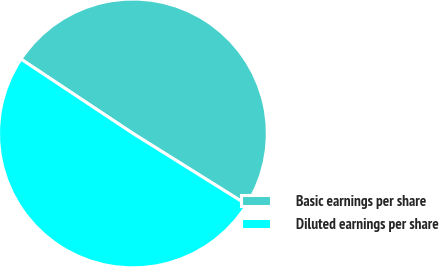<chart> <loc_0><loc_0><loc_500><loc_500><pie_chart><fcel>Basic earnings per share<fcel>Diluted earnings per share<nl><fcel>49.56%<fcel>50.44%<nl></chart> 